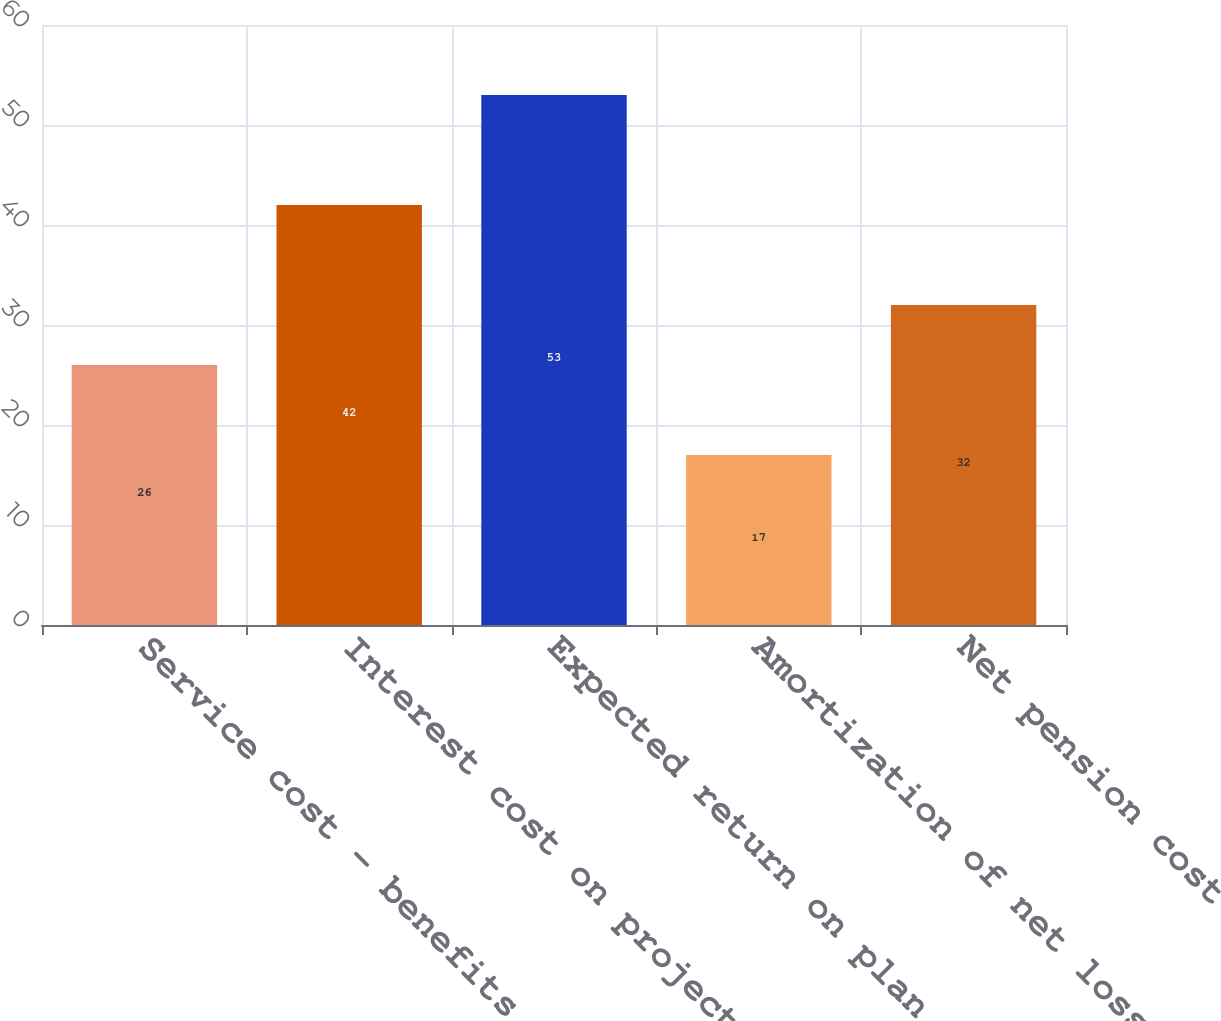<chart> <loc_0><loc_0><loc_500><loc_500><bar_chart><fcel>Service cost - benefits earned<fcel>Interest cost on projected<fcel>Expected return on plan assets<fcel>Amortization of net loss &<fcel>Net pension cost<nl><fcel>26<fcel>42<fcel>53<fcel>17<fcel>32<nl></chart> 